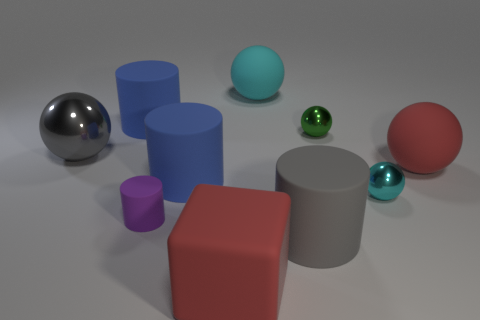Subtract all large gray shiny spheres. How many spheres are left? 4 Subtract all green blocks. How many cyan spheres are left? 2 Subtract all red balls. How many balls are left? 4 Subtract all cubes. How many objects are left? 9 Subtract 1 cylinders. How many cylinders are left? 3 Subtract all gray rubber objects. Subtract all gray cylinders. How many objects are left? 8 Add 3 green balls. How many green balls are left? 4 Add 5 blue things. How many blue things exist? 7 Subtract 1 green balls. How many objects are left? 9 Subtract all blue cubes. Subtract all red spheres. How many cubes are left? 1 